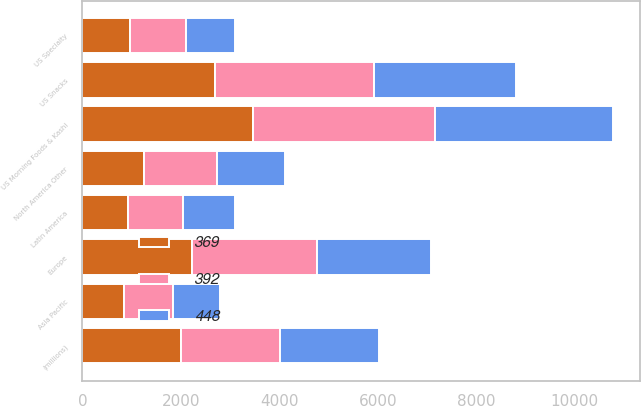Convert chart to OTSL. <chart><loc_0><loc_0><loc_500><loc_500><stacked_bar_chart><ecel><fcel>(millions)<fcel>US Morning Foods & Kashi<fcel>US Snacks<fcel>US Specialty<fcel>North America Other<fcel>Europe<fcel>Latin America<fcel>Asia Pacific<nl><fcel>392<fcel>2012<fcel>3707<fcel>3226<fcel>1121<fcel>1485<fcel>2527<fcel>1121<fcel>1010<nl><fcel>448<fcel>2011<fcel>3611<fcel>2883<fcel>1008<fcel>1371<fcel>2334<fcel>1049<fcel>942<nl><fcel>369<fcel>2010<fcel>3463<fcel>2704<fcel>975<fcel>1260<fcel>2230<fcel>923<fcel>842<nl></chart> 